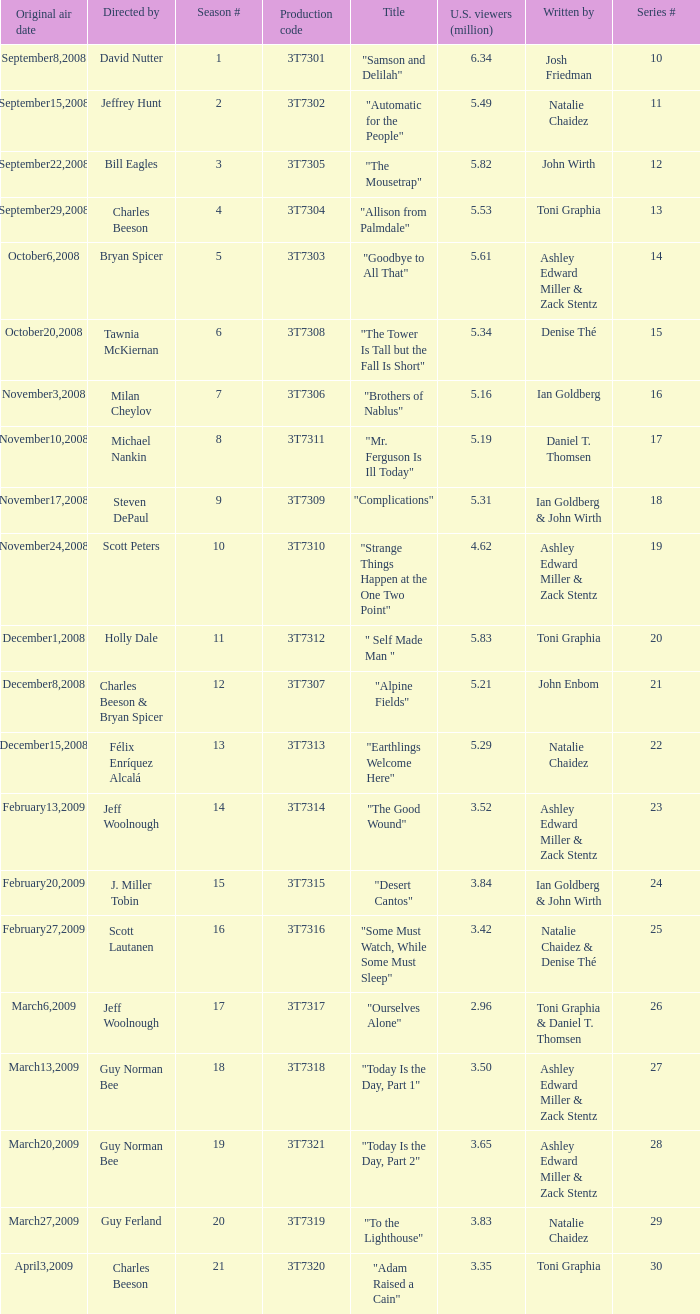Write the full table. {'header': ['Original air date', 'Directed by', 'Season #', 'Production code', 'Title', 'U.S. viewers (million)', 'Written by', 'Series #'], 'rows': [['September8,2008', 'David Nutter', '1', '3T7301', '"Samson and Delilah"', '6.34', 'Josh Friedman', '10'], ['September15,2008', 'Jeffrey Hunt', '2', '3T7302', '"Automatic for the People"', '5.49', 'Natalie Chaidez', '11'], ['September22,2008', 'Bill Eagles', '3', '3T7305', '"The Mousetrap"', '5.82', 'John Wirth', '12'], ['September29,2008', 'Charles Beeson', '4', '3T7304', '"Allison from Palmdale"', '5.53', 'Toni Graphia', '13'], ['October6,2008', 'Bryan Spicer', '5', '3T7303', '"Goodbye to All That"', '5.61', 'Ashley Edward Miller & Zack Stentz', '14'], ['October20,2008', 'Tawnia McKiernan', '6', '3T7308', '"The Tower Is Tall but the Fall Is Short"', '5.34', 'Denise Thé', '15'], ['November3,2008', 'Milan Cheylov', '7', '3T7306', '"Brothers of Nablus"', '5.16', 'Ian Goldberg', '16'], ['November10,2008', 'Michael Nankin', '8', '3T7311', '"Mr. Ferguson Is Ill Today"', '5.19', 'Daniel T. Thomsen', '17'], ['November17,2008', 'Steven DePaul', '9', '3T7309', '"Complications"', '5.31', 'Ian Goldberg & John Wirth', '18'], ['November24,2008', 'Scott Peters', '10', '3T7310', '"Strange Things Happen at the One Two Point"', '4.62', 'Ashley Edward Miller & Zack Stentz', '19'], ['December1,2008', 'Holly Dale', '11', '3T7312', '" Self Made Man "', '5.83', 'Toni Graphia', '20'], ['December8,2008', 'Charles Beeson & Bryan Spicer', '12', '3T7307', '"Alpine Fields"', '5.21', 'John Enbom', '21'], ['December15,2008', 'Félix Enríquez Alcalá', '13', '3T7313', '"Earthlings Welcome Here"', '5.29', 'Natalie Chaidez', '22'], ['February13,2009', 'Jeff Woolnough', '14', '3T7314', '"The Good Wound"', '3.52', 'Ashley Edward Miller & Zack Stentz', '23'], ['February20,2009', 'J. Miller Tobin', '15', '3T7315', '"Desert Cantos"', '3.84', 'Ian Goldberg & John Wirth', '24'], ['February27,2009', 'Scott Lautanen', '16', '3T7316', '"Some Must Watch, While Some Must Sleep"', '3.42', 'Natalie Chaidez & Denise Thé', '25'], ['March6,2009', 'Jeff Woolnough', '17', '3T7317', '"Ourselves Alone"', '2.96', 'Toni Graphia & Daniel T. Thomsen', '26'], ['March13,2009', 'Guy Norman Bee', '18', '3T7318', '"Today Is the Day, Part 1"', '3.50', 'Ashley Edward Miller & Zack Stentz', '27'], ['March20,2009', 'Guy Norman Bee', '19', '3T7321', '"Today Is the Day, Part 2"', '3.65', 'Ashley Edward Miller & Zack Stentz', '28'], ['March27,2009', 'Guy Ferland', '20', '3T7319', '"To the Lighthouse"', '3.83', 'Natalie Chaidez', '29'], ['April3,2009', 'Charles Beeson', '21', '3T7320', '"Adam Raised a Cain"', '3.35', 'Toni Graphia', '30']]} Which episode number drew in 3.84 million viewers in the U.S.? 24.0. 